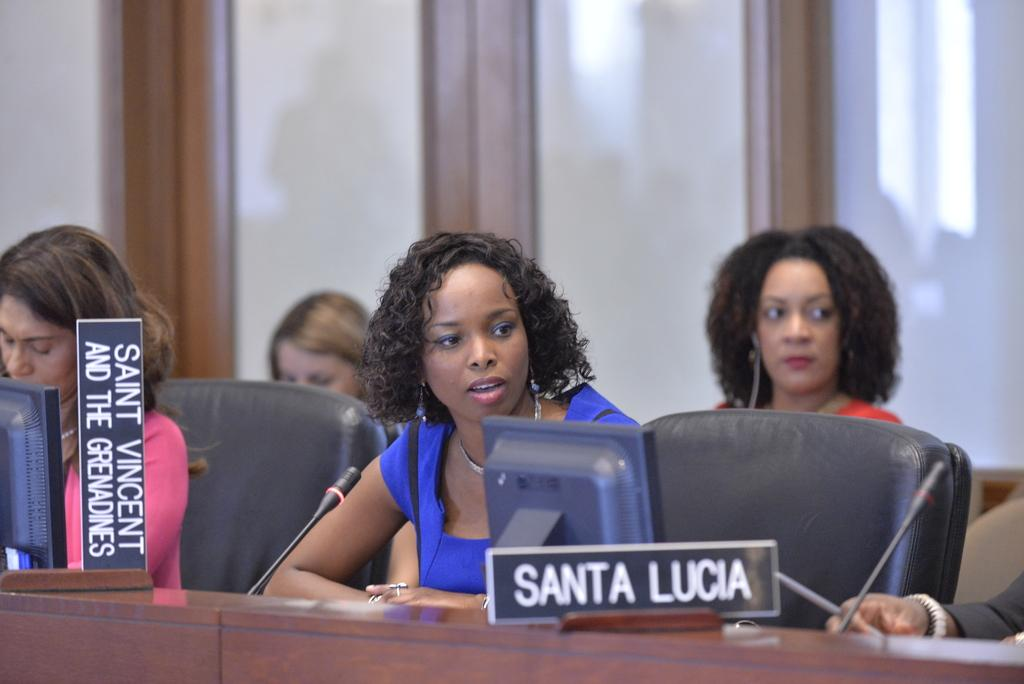How many people are in the image? There is a group of people in the image. What are the people doing in the image? The people are sitting on chairs. What is on the table in the image? There are mice and a screen on the table. What might the people be using the screen for? It is not clear from the image what the purpose of the screen is. What type of flowers are on the table in the image? There are no flowers present on the table in the image. 